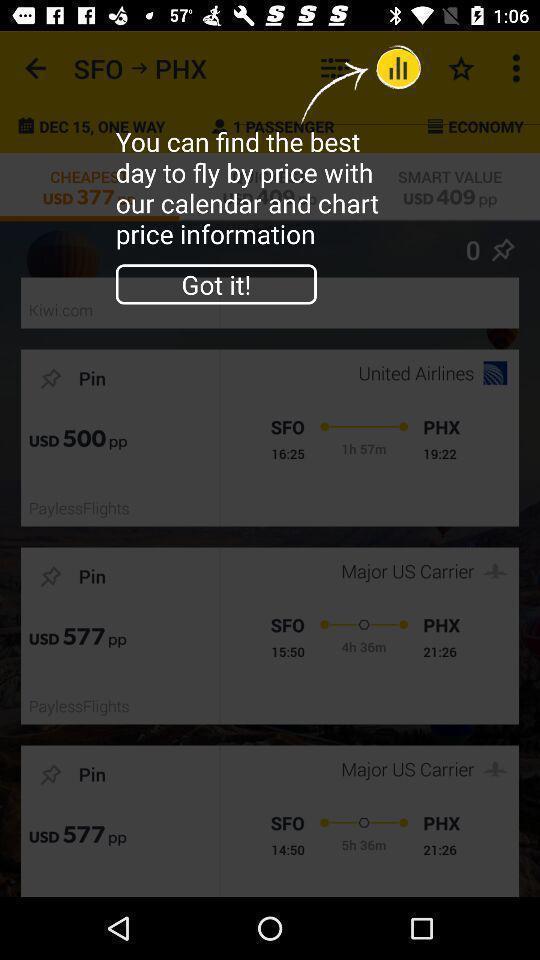Tell me what you see in this picture. Screen showing an option with got it option. 